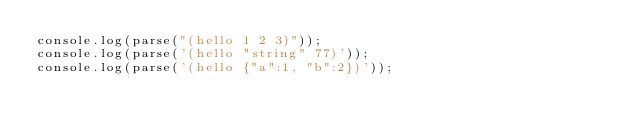Convert code to text. <code><loc_0><loc_0><loc_500><loc_500><_JavaScript_>console.log(parse("(hello 1 2 3)"));
console.log(parse('(hello "string" 77)'));
console.log(parse('(hello {"a":1, "b":2})'));</code> 